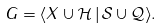<formula> <loc_0><loc_0><loc_500><loc_500>G = \langle X \cup \mathcal { H } \, | \, \mathcal { S } \cup \mathcal { Q } \rangle .</formula> 